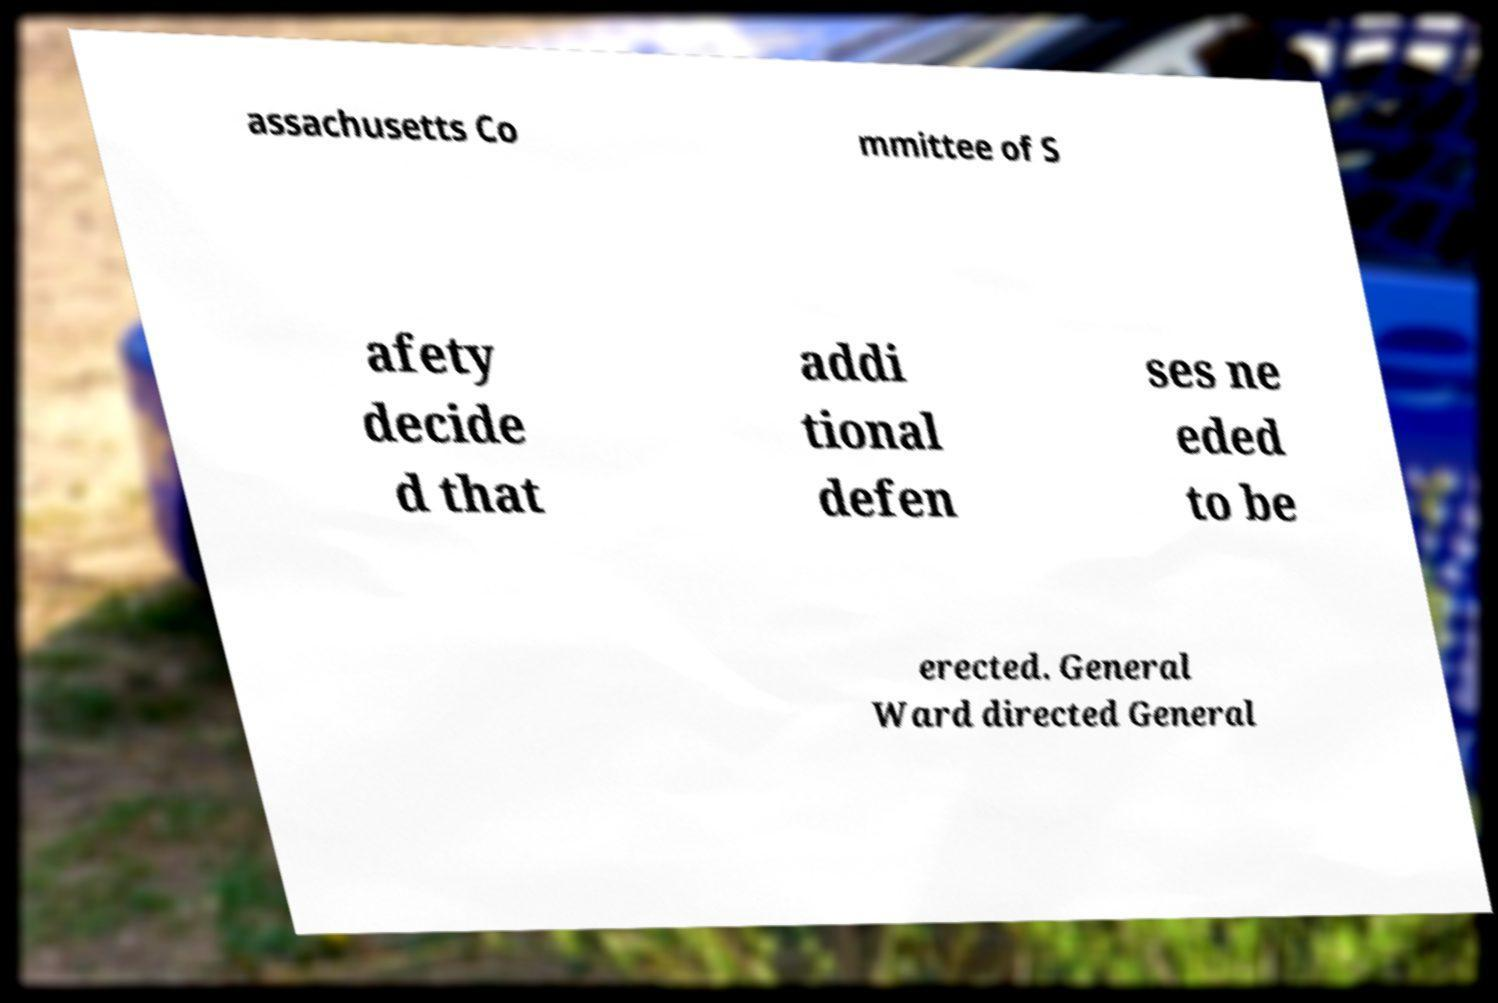I need the written content from this picture converted into text. Can you do that? assachusetts Co mmittee of S afety decide d that addi tional defen ses ne eded to be erected. General Ward directed General 